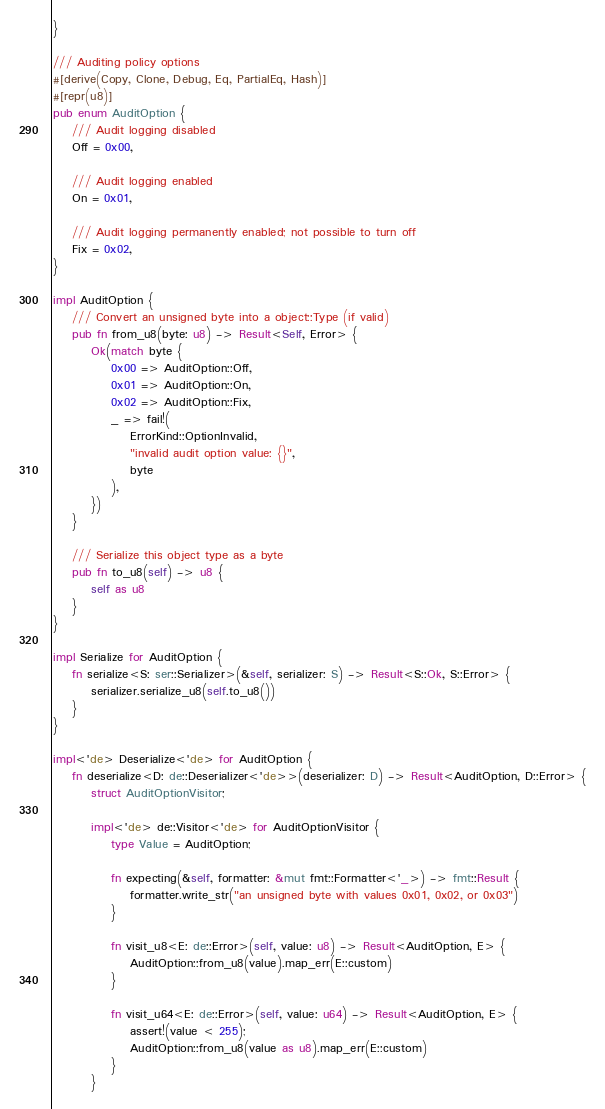<code> <loc_0><loc_0><loc_500><loc_500><_Rust_>}

/// Auditing policy options
#[derive(Copy, Clone, Debug, Eq, PartialEq, Hash)]
#[repr(u8)]
pub enum AuditOption {
    /// Audit logging disabled
    Off = 0x00,

    /// Audit logging enabled
    On = 0x01,

    /// Audit logging permanently enabled; not possible to turn off
    Fix = 0x02,
}

impl AuditOption {
    /// Convert an unsigned byte into a object::Type (if valid)
    pub fn from_u8(byte: u8) -> Result<Self, Error> {
        Ok(match byte {
            0x00 => AuditOption::Off,
            0x01 => AuditOption::On,
            0x02 => AuditOption::Fix,
            _ => fail!(
                ErrorKind::OptionInvalid,
                "invalid audit option value: {}",
                byte
            ),
        })
    }

    /// Serialize this object type as a byte
    pub fn to_u8(self) -> u8 {
        self as u8
    }
}

impl Serialize for AuditOption {
    fn serialize<S: ser::Serializer>(&self, serializer: S) -> Result<S::Ok, S::Error> {
        serializer.serialize_u8(self.to_u8())
    }
}

impl<'de> Deserialize<'de> for AuditOption {
    fn deserialize<D: de::Deserializer<'de>>(deserializer: D) -> Result<AuditOption, D::Error> {
        struct AuditOptionVisitor;

        impl<'de> de::Visitor<'de> for AuditOptionVisitor {
            type Value = AuditOption;

            fn expecting(&self, formatter: &mut fmt::Formatter<'_>) -> fmt::Result {
                formatter.write_str("an unsigned byte with values 0x01, 0x02, or 0x03")
            }

            fn visit_u8<E: de::Error>(self, value: u8) -> Result<AuditOption, E> {
                AuditOption::from_u8(value).map_err(E::custom)
            }

            fn visit_u64<E: de::Error>(self, value: u64) -> Result<AuditOption, E> {
                assert!(value < 255);
                AuditOption::from_u8(value as u8).map_err(E::custom)
            }
        }
</code> 